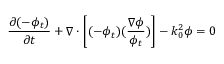<formula> <loc_0><loc_0><loc_500><loc_500>\frac { \partial ( - \phi _ { t } ) } { \partial t } + \nabla \cdot \left [ ( - \phi _ { t } ) ( \frac { \nabla \phi } { \phi _ { t } } ) \right ] - k _ { 0 } ^ { 2 } \phi = 0</formula> 